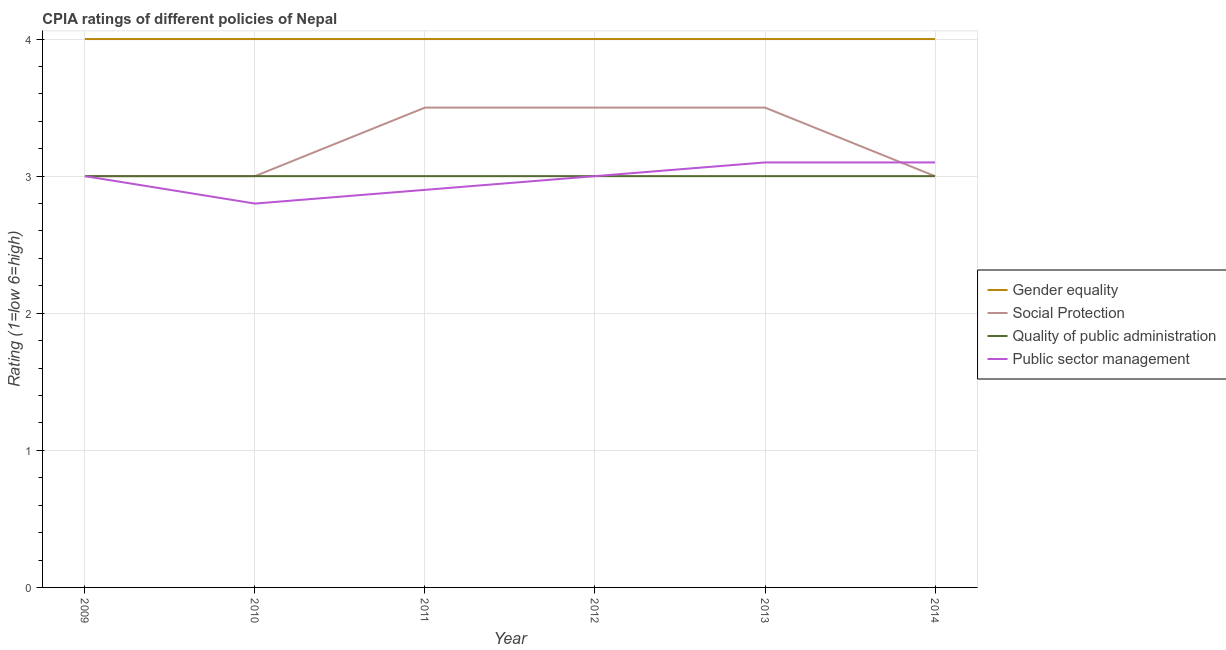Does the line corresponding to cpia rating of public sector management intersect with the line corresponding to cpia rating of social protection?
Offer a terse response. Yes. What is the cpia rating of public sector management in 2012?
Provide a short and direct response. 3. Across all years, what is the maximum cpia rating of social protection?
Offer a very short reply. 3.5. Across all years, what is the minimum cpia rating of quality of public administration?
Your answer should be compact. 3. In which year was the cpia rating of gender equality maximum?
Give a very brief answer. 2009. In which year was the cpia rating of quality of public administration minimum?
Your answer should be compact. 2009. What is the total cpia rating of public sector management in the graph?
Offer a very short reply. 17.9. What is the difference between the cpia rating of gender equality in 2012 and that in 2014?
Ensure brevity in your answer.  0. What is the difference between the cpia rating of public sector management in 2012 and the cpia rating of quality of public administration in 2009?
Make the answer very short. 0. In the year 2009, what is the difference between the cpia rating of public sector management and cpia rating of gender equality?
Make the answer very short. -1. What is the ratio of the cpia rating of quality of public administration in 2011 to that in 2014?
Your answer should be very brief. 1. What is the difference between the highest and the lowest cpia rating of public sector management?
Offer a very short reply. 0.3. Is the sum of the cpia rating of public sector management in 2012 and 2013 greater than the maximum cpia rating of gender equality across all years?
Your response must be concise. Yes. Is it the case that in every year, the sum of the cpia rating of quality of public administration and cpia rating of public sector management is greater than the sum of cpia rating of gender equality and cpia rating of social protection?
Your response must be concise. No. Does the cpia rating of social protection monotonically increase over the years?
Your response must be concise. No. Is the cpia rating of social protection strictly less than the cpia rating of quality of public administration over the years?
Ensure brevity in your answer.  No. How many lines are there?
Provide a short and direct response. 4. How many years are there in the graph?
Provide a short and direct response. 6. Are the values on the major ticks of Y-axis written in scientific E-notation?
Provide a succinct answer. No. Where does the legend appear in the graph?
Offer a very short reply. Center right. What is the title of the graph?
Offer a terse response. CPIA ratings of different policies of Nepal. Does "Permanent crop land" appear as one of the legend labels in the graph?
Offer a very short reply. No. What is the Rating (1=low 6=high) of Gender equality in 2009?
Offer a very short reply. 4. What is the Rating (1=low 6=high) in Social Protection in 2009?
Ensure brevity in your answer.  3. What is the Rating (1=low 6=high) in Quality of public administration in 2009?
Keep it short and to the point. 3. What is the Rating (1=low 6=high) in Public sector management in 2009?
Your answer should be compact. 3. What is the Rating (1=low 6=high) of Gender equality in 2010?
Provide a succinct answer. 4. What is the Rating (1=low 6=high) of Public sector management in 2010?
Provide a short and direct response. 2.8. What is the Rating (1=low 6=high) in Social Protection in 2011?
Provide a short and direct response. 3.5. What is the Rating (1=low 6=high) in Public sector management in 2011?
Make the answer very short. 2.9. What is the Rating (1=low 6=high) in Gender equality in 2013?
Your answer should be very brief. 4. What is the Rating (1=low 6=high) in Social Protection in 2013?
Keep it short and to the point. 3.5. What is the Rating (1=low 6=high) of Quality of public administration in 2013?
Your response must be concise. 3. What is the Rating (1=low 6=high) in Public sector management in 2014?
Your answer should be compact. 3.1. Across all years, what is the maximum Rating (1=low 6=high) of Social Protection?
Make the answer very short. 3.5. Across all years, what is the maximum Rating (1=low 6=high) of Quality of public administration?
Your answer should be very brief. 3. Across all years, what is the maximum Rating (1=low 6=high) of Public sector management?
Provide a short and direct response. 3.1. Across all years, what is the minimum Rating (1=low 6=high) of Gender equality?
Give a very brief answer. 4. Across all years, what is the minimum Rating (1=low 6=high) in Social Protection?
Your answer should be compact. 3. Across all years, what is the minimum Rating (1=low 6=high) in Quality of public administration?
Make the answer very short. 3. Across all years, what is the minimum Rating (1=low 6=high) of Public sector management?
Provide a short and direct response. 2.8. What is the total Rating (1=low 6=high) of Quality of public administration in the graph?
Your response must be concise. 18. What is the total Rating (1=low 6=high) in Public sector management in the graph?
Offer a terse response. 17.9. What is the difference between the Rating (1=low 6=high) in Gender equality in 2009 and that in 2010?
Keep it short and to the point. 0. What is the difference between the Rating (1=low 6=high) in Social Protection in 2009 and that in 2010?
Ensure brevity in your answer.  0. What is the difference between the Rating (1=low 6=high) of Gender equality in 2009 and that in 2011?
Ensure brevity in your answer.  0. What is the difference between the Rating (1=low 6=high) of Social Protection in 2009 and that in 2011?
Offer a terse response. -0.5. What is the difference between the Rating (1=low 6=high) in Public sector management in 2009 and that in 2011?
Give a very brief answer. 0.1. What is the difference between the Rating (1=low 6=high) in Social Protection in 2009 and that in 2012?
Ensure brevity in your answer.  -0.5. What is the difference between the Rating (1=low 6=high) in Quality of public administration in 2009 and that in 2012?
Make the answer very short. 0. What is the difference between the Rating (1=low 6=high) of Public sector management in 2009 and that in 2012?
Offer a very short reply. 0. What is the difference between the Rating (1=low 6=high) in Gender equality in 2009 and that in 2013?
Give a very brief answer. 0. What is the difference between the Rating (1=low 6=high) of Social Protection in 2009 and that in 2013?
Offer a terse response. -0.5. What is the difference between the Rating (1=low 6=high) in Quality of public administration in 2009 and that in 2013?
Provide a succinct answer. 0. What is the difference between the Rating (1=low 6=high) in Public sector management in 2009 and that in 2013?
Your answer should be very brief. -0.1. What is the difference between the Rating (1=low 6=high) in Public sector management in 2009 and that in 2014?
Offer a very short reply. -0.1. What is the difference between the Rating (1=low 6=high) in Social Protection in 2010 and that in 2011?
Your response must be concise. -0.5. What is the difference between the Rating (1=low 6=high) in Public sector management in 2010 and that in 2011?
Your answer should be very brief. -0.1. What is the difference between the Rating (1=low 6=high) in Quality of public administration in 2010 and that in 2012?
Make the answer very short. 0. What is the difference between the Rating (1=low 6=high) of Public sector management in 2010 and that in 2012?
Give a very brief answer. -0.2. What is the difference between the Rating (1=low 6=high) of Social Protection in 2010 and that in 2013?
Your answer should be compact. -0.5. What is the difference between the Rating (1=low 6=high) in Quality of public administration in 2010 and that in 2013?
Provide a succinct answer. 0. What is the difference between the Rating (1=low 6=high) in Social Protection in 2010 and that in 2014?
Your response must be concise. 0. What is the difference between the Rating (1=low 6=high) of Quality of public administration in 2010 and that in 2014?
Provide a short and direct response. 0. What is the difference between the Rating (1=low 6=high) in Public sector management in 2010 and that in 2014?
Provide a short and direct response. -0.3. What is the difference between the Rating (1=low 6=high) of Gender equality in 2011 and that in 2012?
Your answer should be very brief. 0. What is the difference between the Rating (1=low 6=high) in Public sector management in 2011 and that in 2012?
Provide a short and direct response. -0.1. What is the difference between the Rating (1=low 6=high) of Gender equality in 2011 and that in 2013?
Give a very brief answer. 0. What is the difference between the Rating (1=low 6=high) in Gender equality in 2011 and that in 2014?
Offer a very short reply. 0. What is the difference between the Rating (1=low 6=high) of Quality of public administration in 2011 and that in 2014?
Your answer should be very brief. 0. What is the difference between the Rating (1=low 6=high) of Gender equality in 2012 and that in 2013?
Your answer should be compact. 0. What is the difference between the Rating (1=low 6=high) of Quality of public administration in 2012 and that in 2013?
Provide a succinct answer. 0. What is the difference between the Rating (1=low 6=high) of Quality of public administration in 2012 and that in 2014?
Give a very brief answer. 0. What is the difference between the Rating (1=low 6=high) in Social Protection in 2013 and that in 2014?
Provide a succinct answer. 0.5. What is the difference between the Rating (1=low 6=high) in Quality of public administration in 2013 and that in 2014?
Keep it short and to the point. 0. What is the difference between the Rating (1=low 6=high) in Gender equality in 2009 and the Rating (1=low 6=high) in Social Protection in 2010?
Offer a very short reply. 1. What is the difference between the Rating (1=low 6=high) in Gender equality in 2009 and the Rating (1=low 6=high) in Quality of public administration in 2010?
Give a very brief answer. 1. What is the difference between the Rating (1=low 6=high) in Social Protection in 2009 and the Rating (1=low 6=high) in Public sector management in 2010?
Make the answer very short. 0.2. What is the difference between the Rating (1=low 6=high) of Gender equality in 2009 and the Rating (1=low 6=high) of Public sector management in 2011?
Offer a very short reply. 1.1. What is the difference between the Rating (1=low 6=high) in Gender equality in 2009 and the Rating (1=low 6=high) in Quality of public administration in 2012?
Your answer should be very brief. 1. What is the difference between the Rating (1=low 6=high) in Quality of public administration in 2009 and the Rating (1=low 6=high) in Public sector management in 2012?
Ensure brevity in your answer.  0. What is the difference between the Rating (1=low 6=high) in Gender equality in 2009 and the Rating (1=low 6=high) in Public sector management in 2013?
Your answer should be compact. 0.9. What is the difference between the Rating (1=low 6=high) of Quality of public administration in 2009 and the Rating (1=low 6=high) of Public sector management in 2013?
Your answer should be very brief. -0.1. What is the difference between the Rating (1=low 6=high) of Gender equality in 2009 and the Rating (1=low 6=high) of Social Protection in 2014?
Your answer should be compact. 1. What is the difference between the Rating (1=low 6=high) in Gender equality in 2009 and the Rating (1=low 6=high) in Quality of public administration in 2014?
Keep it short and to the point. 1. What is the difference between the Rating (1=low 6=high) in Social Protection in 2009 and the Rating (1=low 6=high) in Quality of public administration in 2014?
Give a very brief answer. 0. What is the difference between the Rating (1=low 6=high) of Social Protection in 2009 and the Rating (1=low 6=high) of Public sector management in 2014?
Ensure brevity in your answer.  -0.1. What is the difference between the Rating (1=low 6=high) of Quality of public administration in 2009 and the Rating (1=low 6=high) of Public sector management in 2014?
Your response must be concise. -0.1. What is the difference between the Rating (1=low 6=high) in Gender equality in 2010 and the Rating (1=low 6=high) in Quality of public administration in 2011?
Keep it short and to the point. 1. What is the difference between the Rating (1=low 6=high) in Social Protection in 2010 and the Rating (1=low 6=high) in Quality of public administration in 2011?
Your response must be concise. 0. What is the difference between the Rating (1=low 6=high) in Quality of public administration in 2010 and the Rating (1=low 6=high) in Public sector management in 2011?
Your answer should be very brief. 0.1. What is the difference between the Rating (1=low 6=high) in Gender equality in 2010 and the Rating (1=low 6=high) in Quality of public administration in 2012?
Offer a terse response. 1. What is the difference between the Rating (1=low 6=high) in Social Protection in 2010 and the Rating (1=low 6=high) in Public sector management in 2012?
Ensure brevity in your answer.  0. What is the difference between the Rating (1=low 6=high) of Quality of public administration in 2010 and the Rating (1=low 6=high) of Public sector management in 2012?
Your answer should be very brief. 0. What is the difference between the Rating (1=low 6=high) of Gender equality in 2010 and the Rating (1=low 6=high) of Quality of public administration in 2013?
Ensure brevity in your answer.  1. What is the difference between the Rating (1=low 6=high) of Social Protection in 2010 and the Rating (1=low 6=high) of Quality of public administration in 2013?
Your answer should be very brief. 0. What is the difference between the Rating (1=low 6=high) in Quality of public administration in 2010 and the Rating (1=low 6=high) in Public sector management in 2013?
Ensure brevity in your answer.  -0.1. What is the difference between the Rating (1=low 6=high) in Gender equality in 2010 and the Rating (1=low 6=high) in Public sector management in 2014?
Give a very brief answer. 0.9. What is the difference between the Rating (1=low 6=high) in Social Protection in 2010 and the Rating (1=low 6=high) in Quality of public administration in 2014?
Your response must be concise. 0. What is the difference between the Rating (1=low 6=high) in Social Protection in 2010 and the Rating (1=low 6=high) in Public sector management in 2014?
Your response must be concise. -0.1. What is the difference between the Rating (1=low 6=high) of Gender equality in 2011 and the Rating (1=low 6=high) of Social Protection in 2012?
Keep it short and to the point. 0.5. What is the difference between the Rating (1=low 6=high) in Social Protection in 2011 and the Rating (1=low 6=high) in Quality of public administration in 2012?
Give a very brief answer. 0.5. What is the difference between the Rating (1=low 6=high) of Social Protection in 2011 and the Rating (1=low 6=high) of Public sector management in 2012?
Your answer should be very brief. 0.5. What is the difference between the Rating (1=low 6=high) in Gender equality in 2011 and the Rating (1=low 6=high) in Social Protection in 2013?
Your answer should be compact. 0.5. What is the difference between the Rating (1=low 6=high) in Quality of public administration in 2011 and the Rating (1=low 6=high) in Public sector management in 2013?
Your answer should be very brief. -0.1. What is the difference between the Rating (1=low 6=high) in Gender equality in 2011 and the Rating (1=low 6=high) in Social Protection in 2014?
Provide a short and direct response. 1. What is the difference between the Rating (1=low 6=high) in Gender equality in 2011 and the Rating (1=low 6=high) in Public sector management in 2014?
Ensure brevity in your answer.  0.9. What is the difference between the Rating (1=low 6=high) of Social Protection in 2011 and the Rating (1=low 6=high) of Public sector management in 2014?
Offer a terse response. 0.4. What is the difference between the Rating (1=low 6=high) of Quality of public administration in 2011 and the Rating (1=low 6=high) of Public sector management in 2014?
Offer a terse response. -0.1. What is the difference between the Rating (1=low 6=high) of Gender equality in 2012 and the Rating (1=low 6=high) of Social Protection in 2013?
Provide a succinct answer. 0.5. What is the difference between the Rating (1=low 6=high) of Social Protection in 2012 and the Rating (1=low 6=high) of Public sector management in 2013?
Provide a short and direct response. 0.4. What is the difference between the Rating (1=low 6=high) of Quality of public administration in 2012 and the Rating (1=low 6=high) of Public sector management in 2013?
Give a very brief answer. -0.1. What is the difference between the Rating (1=low 6=high) of Gender equality in 2012 and the Rating (1=low 6=high) of Quality of public administration in 2014?
Offer a very short reply. 1. What is the difference between the Rating (1=low 6=high) in Gender equality in 2012 and the Rating (1=low 6=high) in Public sector management in 2014?
Offer a terse response. 0.9. What is the difference between the Rating (1=low 6=high) of Gender equality in 2013 and the Rating (1=low 6=high) of Quality of public administration in 2014?
Provide a short and direct response. 1. What is the difference between the Rating (1=low 6=high) in Social Protection in 2013 and the Rating (1=low 6=high) in Quality of public administration in 2014?
Make the answer very short. 0.5. What is the difference between the Rating (1=low 6=high) of Social Protection in 2013 and the Rating (1=low 6=high) of Public sector management in 2014?
Provide a short and direct response. 0.4. What is the difference between the Rating (1=low 6=high) in Quality of public administration in 2013 and the Rating (1=low 6=high) in Public sector management in 2014?
Offer a very short reply. -0.1. What is the average Rating (1=low 6=high) of Gender equality per year?
Give a very brief answer. 4. What is the average Rating (1=low 6=high) of Public sector management per year?
Ensure brevity in your answer.  2.98. In the year 2009, what is the difference between the Rating (1=low 6=high) of Gender equality and Rating (1=low 6=high) of Quality of public administration?
Offer a terse response. 1. In the year 2009, what is the difference between the Rating (1=low 6=high) in Gender equality and Rating (1=low 6=high) in Public sector management?
Offer a very short reply. 1. In the year 2009, what is the difference between the Rating (1=low 6=high) of Social Protection and Rating (1=low 6=high) of Quality of public administration?
Provide a short and direct response. 0. In the year 2009, what is the difference between the Rating (1=low 6=high) in Social Protection and Rating (1=low 6=high) in Public sector management?
Make the answer very short. 0. In the year 2010, what is the difference between the Rating (1=low 6=high) in Gender equality and Rating (1=low 6=high) in Social Protection?
Provide a succinct answer. 1. In the year 2010, what is the difference between the Rating (1=low 6=high) of Social Protection and Rating (1=low 6=high) of Quality of public administration?
Your answer should be very brief. 0. In the year 2010, what is the difference between the Rating (1=low 6=high) of Social Protection and Rating (1=low 6=high) of Public sector management?
Give a very brief answer. 0.2. In the year 2010, what is the difference between the Rating (1=low 6=high) in Quality of public administration and Rating (1=low 6=high) in Public sector management?
Your response must be concise. 0.2. In the year 2011, what is the difference between the Rating (1=low 6=high) of Social Protection and Rating (1=low 6=high) of Quality of public administration?
Your answer should be compact. 0.5. In the year 2011, what is the difference between the Rating (1=low 6=high) of Social Protection and Rating (1=low 6=high) of Public sector management?
Ensure brevity in your answer.  0.6. In the year 2011, what is the difference between the Rating (1=low 6=high) of Quality of public administration and Rating (1=low 6=high) of Public sector management?
Make the answer very short. 0.1. In the year 2012, what is the difference between the Rating (1=low 6=high) of Gender equality and Rating (1=low 6=high) of Social Protection?
Offer a terse response. 0.5. In the year 2012, what is the difference between the Rating (1=low 6=high) in Gender equality and Rating (1=low 6=high) in Quality of public administration?
Give a very brief answer. 1. In the year 2013, what is the difference between the Rating (1=low 6=high) of Gender equality and Rating (1=low 6=high) of Social Protection?
Offer a terse response. 0.5. In the year 2013, what is the difference between the Rating (1=low 6=high) in Gender equality and Rating (1=low 6=high) in Quality of public administration?
Offer a terse response. 1. In the year 2013, what is the difference between the Rating (1=low 6=high) in Quality of public administration and Rating (1=low 6=high) in Public sector management?
Your response must be concise. -0.1. In the year 2014, what is the difference between the Rating (1=low 6=high) in Gender equality and Rating (1=low 6=high) in Public sector management?
Provide a short and direct response. 0.9. In the year 2014, what is the difference between the Rating (1=low 6=high) of Quality of public administration and Rating (1=low 6=high) of Public sector management?
Your response must be concise. -0.1. What is the ratio of the Rating (1=low 6=high) in Gender equality in 2009 to that in 2010?
Offer a terse response. 1. What is the ratio of the Rating (1=low 6=high) in Social Protection in 2009 to that in 2010?
Offer a terse response. 1. What is the ratio of the Rating (1=low 6=high) of Public sector management in 2009 to that in 2010?
Provide a short and direct response. 1.07. What is the ratio of the Rating (1=low 6=high) in Public sector management in 2009 to that in 2011?
Give a very brief answer. 1.03. What is the ratio of the Rating (1=low 6=high) of Gender equality in 2009 to that in 2012?
Provide a succinct answer. 1. What is the ratio of the Rating (1=low 6=high) of Public sector management in 2009 to that in 2012?
Make the answer very short. 1. What is the ratio of the Rating (1=low 6=high) of Gender equality in 2009 to that in 2013?
Provide a succinct answer. 1. What is the ratio of the Rating (1=low 6=high) in Quality of public administration in 2009 to that in 2014?
Provide a short and direct response. 1. What is the ratio of the Rating (1=low 6=high) of Public sector management in 2009 to that in 2014?
Provide a short and direct response. 0.97. What is the ratio of the Rating (1=low 6=high) in Gender equality in 2010 to that in 2011?
Your answer should be compact. 1. What is the ratio of the Rating (1=low 6=high) of Social Protection in 2010 to that in 2011?
Provide a short and direct response. 0.86. What is the ratio of the Rating (1=low 6=high) of Public sector management in 2010 to that in 2011?
Provide a short and direct response. 0.97. What is the ratio of the Rating (1=low 6=high) in Gender equality in 2010 to that in 2012?
Give a very brief answer. 1. What is the ratio of the Rating (1=low 6=high) in Social Protection in 2010 to that in 2012?
Your response must be concise. 0.86. What is the ratio of the Rating (1=low 6=high) in Quality of public administration in 2010 to that in 2012?
Keep it short and to the point. 1. What is the ratio of the Rating (1=low 6=high) in Public sector management in 2010 to that in 2013?
Offer a terse response. 0.9. What is the ratio of the Rating (1=low 6=high) in Gender equality in 2010 to that in 2014?
Your answer should be very brief. 1. What is the ratio of the Rating (1=low 6=high) of Quality of public administration in 2010 to that in 2014?
Your answer should be very brief. 1. What is the ratio of the Rating (1=low 6=high) of Public sector management in 2010 to that in 2014?
Make the answer very short. 0.9. What is the ratio of the Rating (1=low 6=high) in Gender equality in 2011 to that in 2012?
Your answer should be compact. 1. What is the ratio of the Rating (1=low 6=high) in Quality of public administration in 2011 to that in 2012?
Provide a succinct answer. 1. What is the ratio of the Rating (1=low 6=high) of Public sector management in 2011 to that in 2012?
Provide a succinct answer. 0.97. What is the ratio of the Rating (1=low 6=high) in Gender equality in 2011 to that in 2013?
Make the answer very short. 1. What is the ratio of the Rating (1=low 6=high) in Social Protection in 2011 to that in 2013?
Ensure brevity in your answer.  1. What is the ratio of the Rating (1=low 6=high) of Public sector management in 2011 to that in 2013?
Ensure brevity in your answer.  0.94. What is the ratio of the Rating (1=low 6=high) of Gender equality in 2011 to that in 2014?
Keep it short and to the point. 1. What is the ratio of the Rating (1=low 6=high) of Quality of public administration in 2011 to that in 2014?
Your answer should be compact. 1. What is the ratio of the Rating (1=low 6=high) of Public sector management in 2011 to that in 2014?
Provide a succinct answer. 0.94. What is the ratio of the Rating (1=low 6=high) of Social Protection in 2012 to that in 2013?
Provide a succinct answer. 1. What is the ratio of the Rating (1=low 6=high) in Quality of public administration in 2012 to that in 2013?
Offer a very short reply. 1. What is the ratio of the Rating (1=low 6=high) of Public sector management in 2012 to that in 2013?
Keep it short and to the point. 0.97. What is the ratio of the Rating (1=low 6=high) in Gender equality in 2013 to that in 2014?
Make the answer very short. 1. What is the ratio of the Rating (1=low 6=high) in Quality of public administration in 2013 to that in 2014?
Give a very brief answer. 1. What is the difference between the highest and the second highest Rating (1=low 6=high) in Quality of public administration?
Offer a terse response. 0. What is the difference between the highest and the second highest Rating (1=low 6=high) of Public sector management?
Offer a terse response. 0. What is the difference between the highest and the lowest Rating (1=low 6=high) of Gender equality?
Give a very brief answer. 0. What is the difference between the highest and the lowest Rating (1=low 6=high) of Social Protection?
Make the answer very short. 0.5. What is the difference between the highest and the lowest Rating (1=low 6=high) of Quality of public administration?
Provide a short and direct response. 0. What is the difference between the highest and the lowest Rating (1=low 6=high) in Public sector management?
Give a very brief answer. 0.3. 